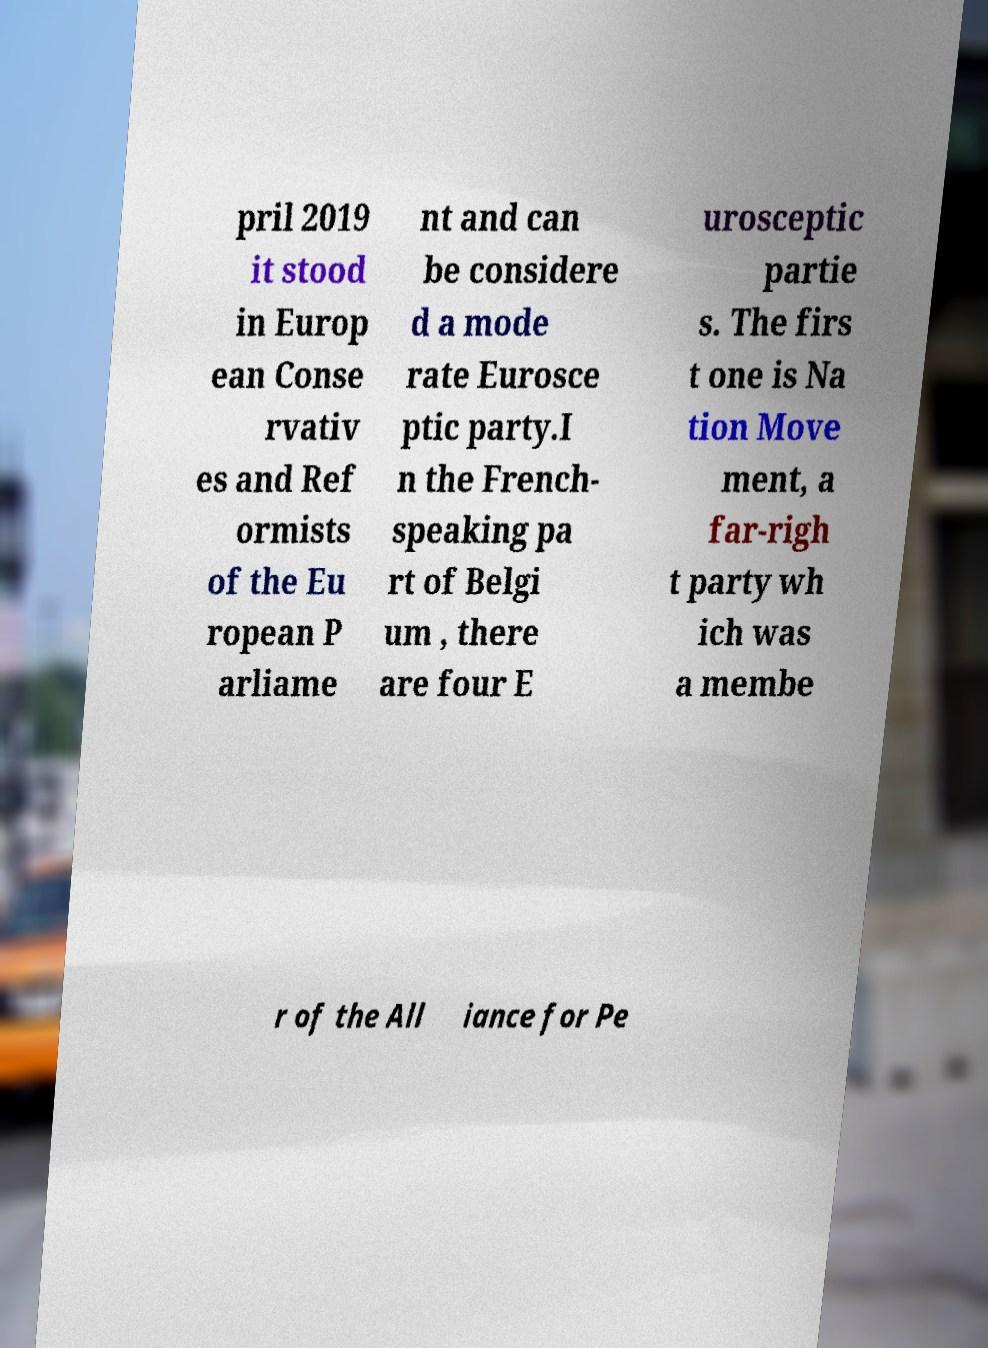What messages or text are displayed in this image? I need them in a readable, typed format. pril 2019 it stood in Europ ean Conse rvativ es and Ref ormists of the Eu ropean P arliame nt and can be considere d a mode rate Eurosce ptic party.I n the French- speaking pa rt of Belgi um , there are four E urosceptic partie s. The firs t one is Na tion Move ment, a far-righ t party wh ich was a membe r of the All iance for Pe 